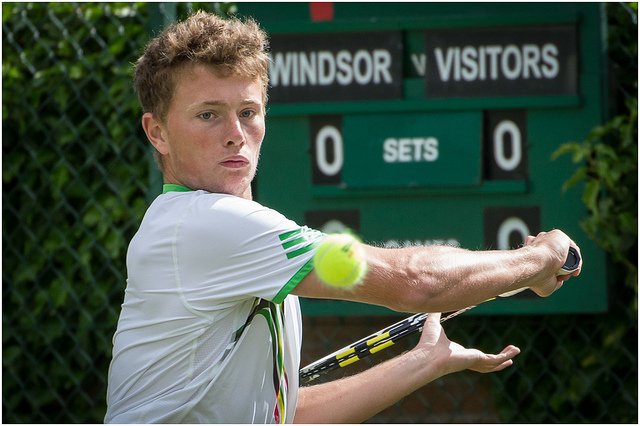Please extract the text content from this image. WINDSOR VISITORS 0 SHETS 0 